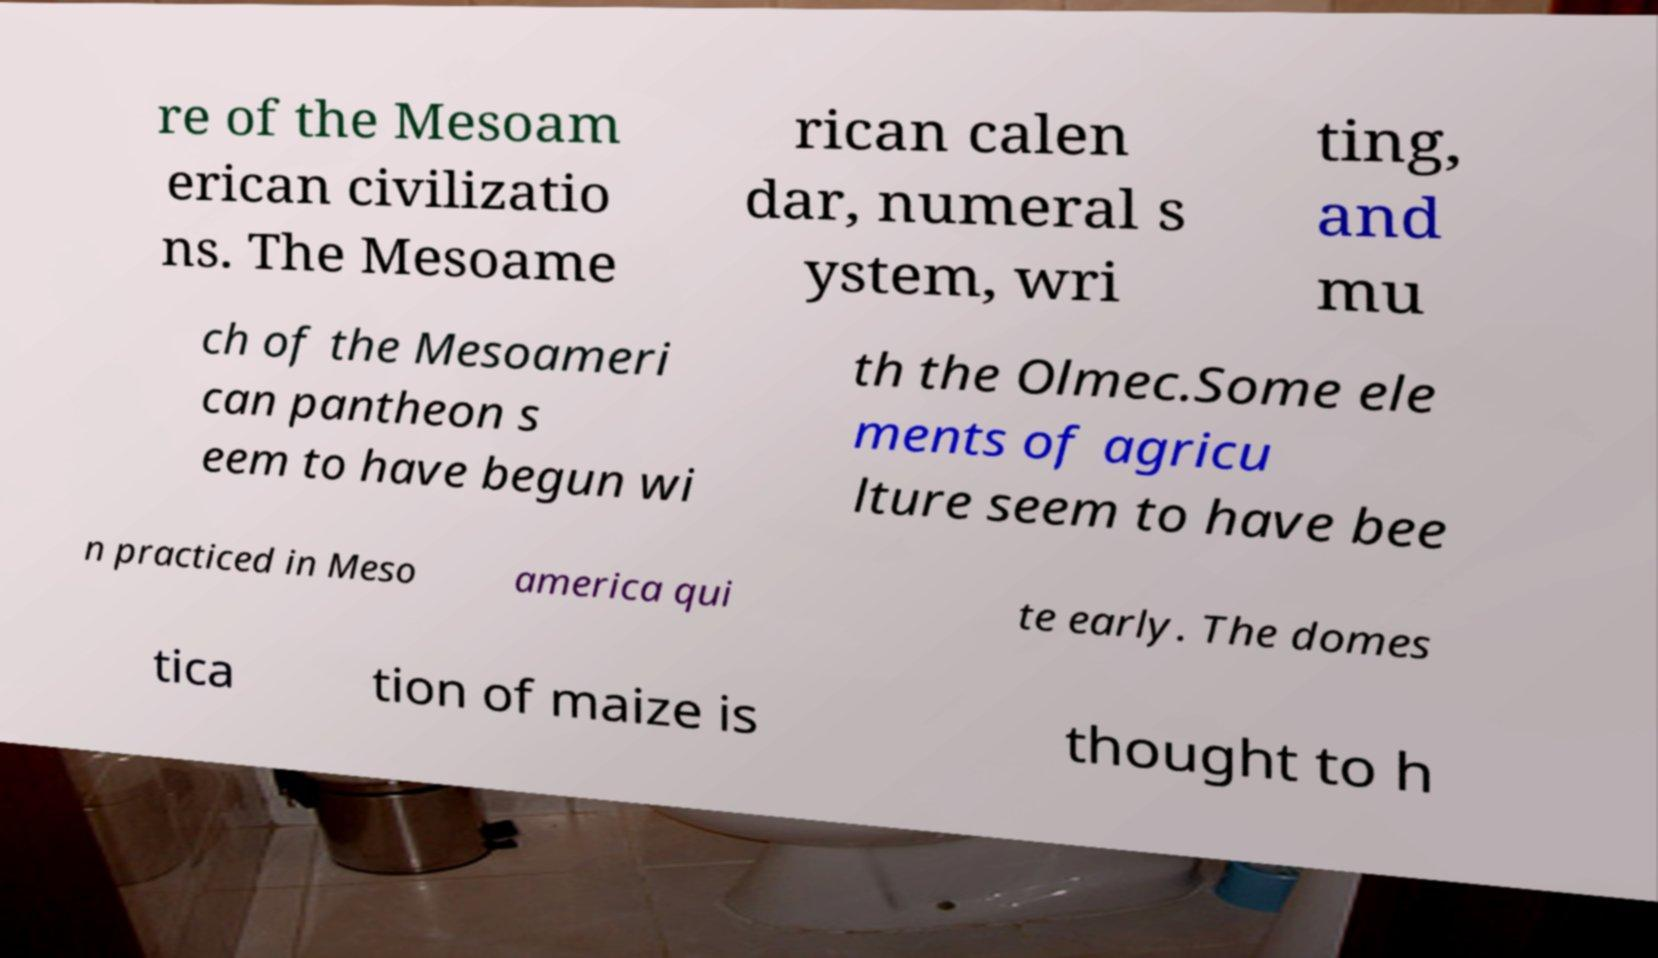Can you read and provide the text displayed in the image?This photo seems to have some interesting text. Can you extract and type it out for me? re of the Mesoam erican civilizatio ns. The Mesoame rican calen dar, numeral s ystem, wri ting, and mu ch of the Mesoameri can pantheon s eem to have begun wi th the Olmec.Some ele ments of agricu lture seem to have bee n practiced in Meso america qui te early. The domes tica tion of maize is thought to h 